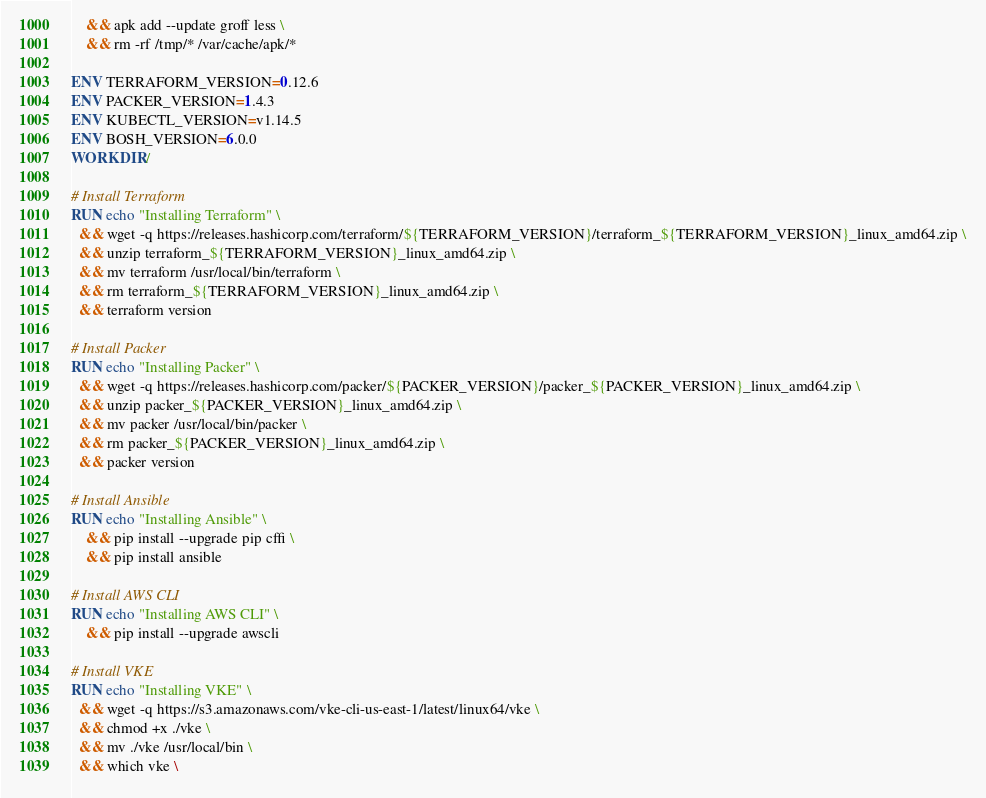Convert code to text. <code><loc_0><loc_0><loc_500><loc_500><_Dockerfile_>    && apk add --update groff less \
    && rm -rf /tmp/* /var/cache/apk/*

ENV TERRAFORM_VERSION=0.12.6
ENV PACKER_VERSION=1.4.3
ENV KUBECTL_VERSION=v1.14.5
ENV BOSH_VERSION=6.0.0
WORKDIR /

# Install Terraform
RUN echo "Installing Terraform" \
  && wget -q https://releases.hashicorp.com/terraform/${TERRAFORM_VERSION}/terraform_${TERRAFORM_VERSION}_linux_amd64.zip \
  && unzip terraform_${TERRAFORM_VERSION}_linux_amd64.zip \
  && mv terraform /usr/local/bin/terraform \
  && rm terraform_${TERRAFORM_VERSION}_linux_amd64.zip \
  && terraform version

# Install Packer
RUN echo "Installing Packer" \
  && wget -q https://releases.hashicorp.com/packer/${PACKER_VERSION}/packer_${PACKER_VERSION}_linux_amd64.zip \
  && unzip packer_${PACKER_VERSION}_linux_amd64.zip \
  && mv packer /usr/local/bin/packer \
  && rm packer_${PACKER_VERSION}_linux_amd64.zip \
  && packer version

# Install Ansible
RUN echo "Installing Ansible" \
    && pip install --upgrade pip cffi \
    && pip install ansible

# Install AWS CLI
RUN echo "Installing AWS CLI" \
    && pip install --upgrade awscli

# Install VKE
RUN echo "Installing VKE" \
  && wget -q https://s3.amazonaws.com/vke-cli-us-east-1/latest/linux64/vke \
  && chmod +x ./vke \
  && mv ./vke /usr/local/bin \
  && which vke \</code> 